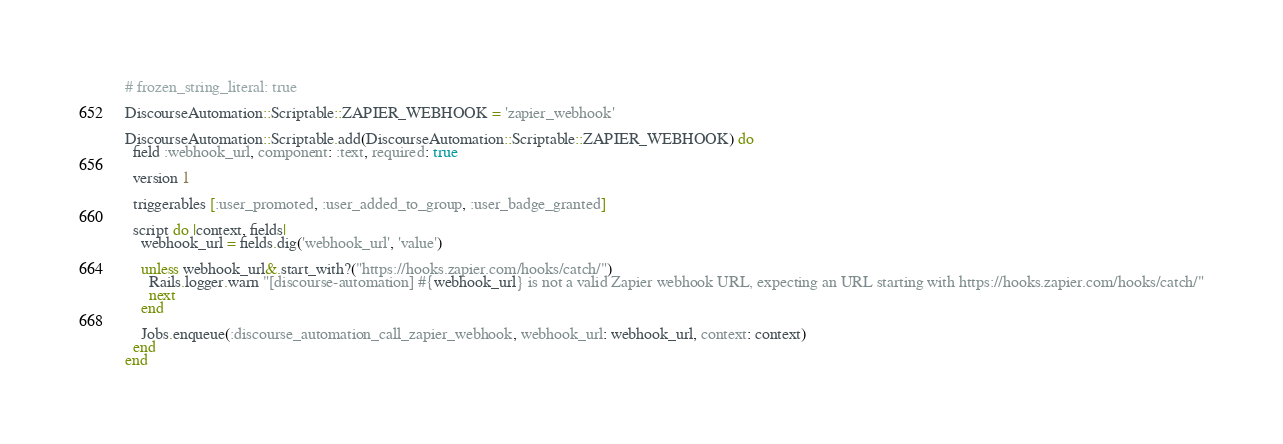<code> <loc_0><loc_0><loc_500><loc_500><_Ruby_># frozen_string_literal: true

DiscourseAutomation::Scriptable::ZAPIER_WEBHOOK = 'zapier_webhook'

DiscourseAutomation::Scriptable.add(DiscourseAutomation::Scriptable::ZAPIER_WEBHOOK) do
  field :webhook_url, component: :text, required: true

  version 1

  triggerables [:user_promoted, :user_added_to_group, :user_badge_granted]

  script do |context, fields|
    webhook_url = fields.dig('webhook_url', 'value')

    unless webhook_url&.start_with?("https://hooks.zapier.com/hooks/catch/")
      Rails.logger.warn "[discourse-automation] #{webhook_url} is not a valid Zapier webhook URL, expecting an URL starting with https://hooks.zapier.com/hooks/catch/"
      next
    end

    Jobs.enqueue(:discourse_automation_call_zapier_webhook, webhook_url: webhook_url, context: context)
  end
end
</code> 